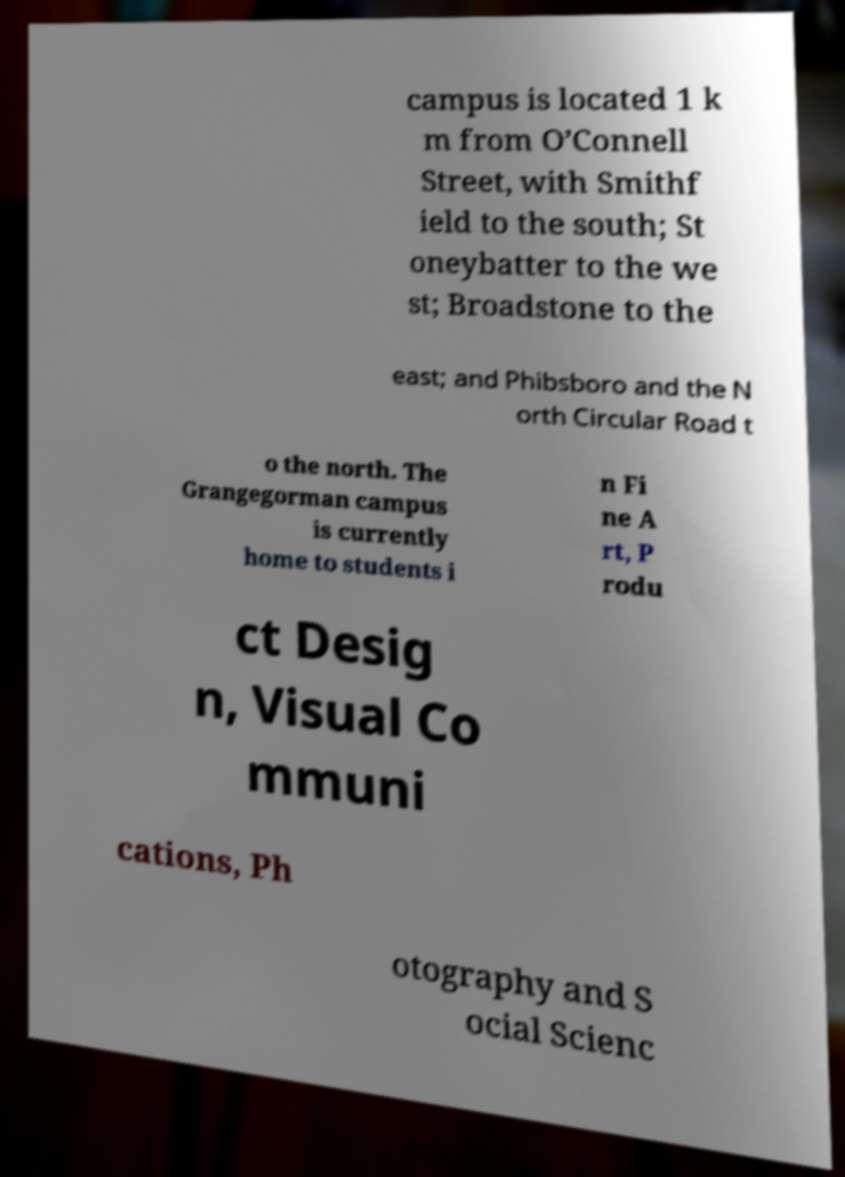Can you read and provide the text displayed in the image?This photo seems to have some interesting text. Can you extract and type it out for me? campus is located 1 k m from O’Connell Street, with Smithf ield to the south; St oneybatter to the we st; Broadstone to the east; and Phibsboro and the N orth Circular Road t o the north. The Grangegorman campus is currently home to students i n Fi ne A rt, P rodu ct Desig n, Visual Co mmuni cations, Ph otography and S ocial Scienc 